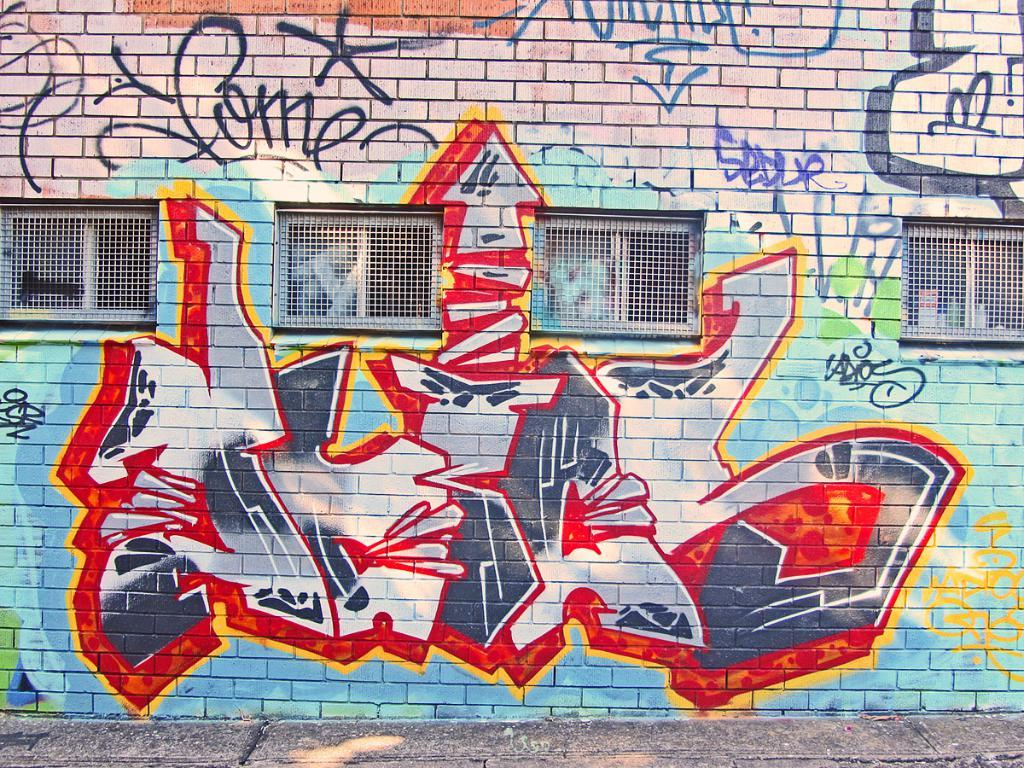What is depicted on the wall in the image? There is graffiti on a wall in the image. Where is the graffiti located in relation to the image? The graffiti is in the center of the image. What else can be seen in the image besides the graffiti? There are windows visible in the image. What is the surface beneath the graffiti in the image? There is a ground at the bottom of the image. What is the name of the person who delivered the parcel in the image? There is no parcel or person delivering a parcel present in the image. How many rooms are visible in the image? There is no room visible in the image; it features graffiti on a wall, windows, and a ground. 